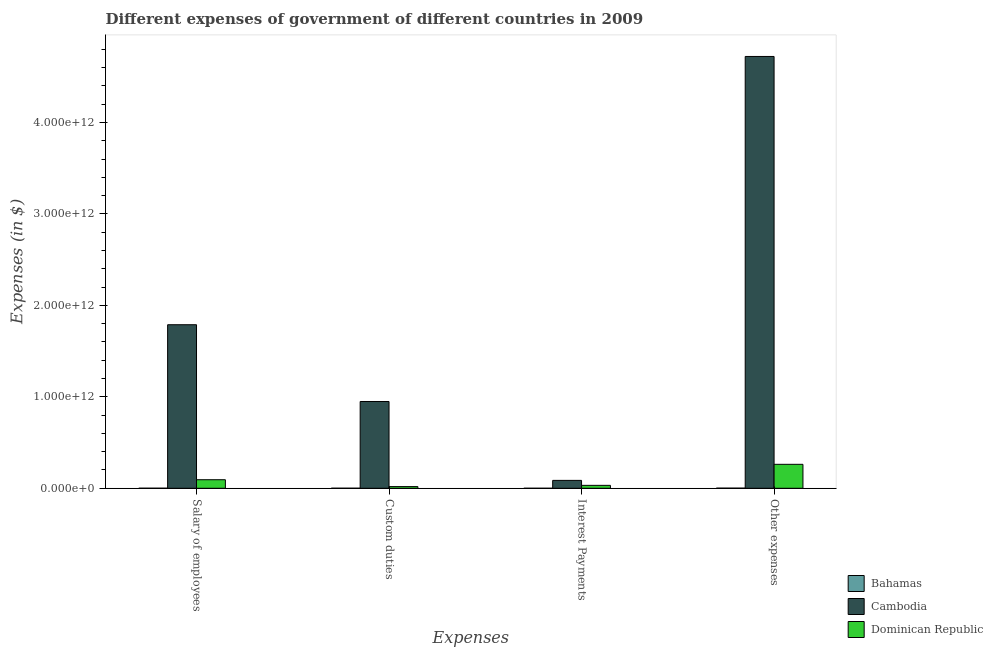How many different coloured bars are there?
Provide a succinct answer. 3. How many groups of bars are there?
Your response must be concise. 4. Are the number of bars on each tick of the X-axis equal?
Offer a very short reply. Yes. How many bars are there on the 2nd tick from the left?
Your response must be concise. 3. How many bars are there on the 2nd tick from the right?
Offer a very short reply. 3. What is the label of the 2nd group of bars from the left?
Your answer should be very brief. Custom duties. What is the amount spent on other expenses in Cambodia?
Your answer should be compact. 4.72e+12. Across all countries, what is the maximum amount spent on salary of employees?
Offer a terse response. 1.79e+12. Across all countries, what is the minimum amount spent on other expenses?
Keep it short and to the point. 1.42e+09. In which country was the amount spent on other expenses maximum?
Provide a succinct answer. Cambodia. In which country was the amount spent on salary of employees minimum?
Give a very brief answer. Bahamas. What is the total amount spent on custom duties in the graph?
Offer a terse response. 9.68e+11. What is the difference between the amount spent on other expenses in Cambodia and that in Bahamas?
Give a very brief answer. 4.72e+12. What is the difference between the amount spent on salary of employees in Cambodia and the amount spent on other expenses in Bahamas?
Give a very brief answer. 1.79e+12. What is the average amount spent on custom duties per country?
Your answer should be very brief. 3.23e+11. What is the difference between the amount spent on salary of employees and amount spent on custom duties in Bahamas?
Your response must be concise. -8.94e+06. In how many countries, is the amount spent on interest payments greater than 3800000000000 $?
Make the answer very short. 0. What is the ratio of the amount spent on other expenses in Bahamas to that in Cambodia?
Give a very brief answer. 0. Is the amount spent on other expenses in Dominican Republic less than that in Bahamas?
Keep it short and to the point. No. What is the difference between the highest and the second highest amount spent on other expenses?
Your response must be concise. 4.46e+12. What is the difference between the highest and the lowest amount spent on custom duties?
Keep it short and to the point. 9.48e+11. Is the sum of the amount spent on interest payments in Bahamas and Dominican Republic greater than the maximum amount spent on salary of employees across all countries?
Keep it short and to the point. No. Is it the case that in every country, the sum of the amount spent on salary of employees and amount spent on custom duties is greater than the sum of amount spent on interest payments and amount spent on other expenses?
Your response must be concise. No. What does the 2nd bar from the left in Interest Payments represents?
Provide a succinct answer. Cambodia. What does the 1st bar from the right in Other expenses represents?
Ensure brevity in your answer.  Dominican Republic. How many bars are there?
Keep it short and to the point. 12. Are all the bars in the graph horizontal?
Offer a terse response. No. How many countries are there in the graph?
Provide a succinct answer. 3. What is the difference between two consecutive major ticks on the Y-axis?
Offer a very short reply. 1.00e+12. Does the graph contain any zero values?
Give a very brief answer. No. Where does the legend appear in the graph?
Offer a terse response. Bottom right. What is the title of the graph?
Ensure brevity in your answer.  Different expenses of government of different countries in 2009. Does "Vanuatu" appear as one of the legend labels in the graph?
Ensure brevity in your answer.  No. What is the label or title of the X-axis?
Provide a short and direct response. Expenses. What is the label or title of the Y-axis?
Give a very brief answer. Expenses (in $). What is the Expenses (in $) of Bahamas in Salary of employees?
Ensure brevity in your answer.  5.73e+08. What is the Expenses (in $) of Cambodia in Salary of employees?
Provide a succinct answer. 1.79e+12. What is the Expenses (in $) of Dominican Republic in Salary of employees?
Your answer should be compact. 9.35e+1. What is the Expenses (in $) of Bahamas in Custom duties?
Offer a terse response. 5.82e+08. What is the Expenses (in $) of Cambodia in Custom duties?
Make the answer very short. 9.49e+11. What is the Expenses (in $) in Dominican Republic in Custom duties?
Ensure brevity in your answer.  1.83e+1. What is the Expenses (in $) of Bahamas in Interest Payments?
Keep it short and to the point. 1.54e+08. What is the Expenses (in $) in Cambodia in Interest Payments?
Keep it short and to the point. 8.63e+1. What is the Expenses (in $) of Dominican Republic in Interest Payments?
Give a very brief answer. 3.20e+1. What is the Expenses (in $) in Bahamas in Other expenses?
Your response must be concise. 1.42e+09. What is the Expenses (in $) of Cambodia in Other expenses?
Offer a very short reply. 4.72e+12. What is the Expenses (in $) of Dominican Republic in Other expenses?
Your answer should be very brief. 2.62e+11. Across all Expenses, what is the maximum Expenses (in $) in Bahamas?
Your answer should be compact. 1.42e+09. Across all Expenses, what is the maximum Expenses (in $) in Cambodia?
Offer a terse response. 4.72e+12. Across all Expenses, what is the maximum Expenses (in $) of Dominican Republic?
Provide a short and direct response. 2.62e+11. Across all Expenses, what is the minimum Expenses (in $) of Bahamas?
Offer a very short reply. 1.54e+08. Across all Expenses, what is the minimum Expenses (in $) of Cambodia?
Your answer should be very brief. 8.63e+1. Across all Expenses, what is the minimum Expenses (in $) of Dominican Republic?
Your answer should be compact. 1.83e+1. What is the total Expenses (in $) of Bahamas in the graph?
Offer a very short reply. 2.73e+09. What is the total Expenses (in $) of Cambodia in the graph?
Your response must be concise. 7.55e+12. What is the total Expenses (in $) in Dominican Republic in the graph?
Your response must be concise. 4.06e+11. What is the difference between the Expenses (in $) in Bahamas in Salary of employees and that in Custom duties?
Provide a succinct answer. -8.94e+06. What is the difference between the Expenses (in $) in Cambodia in Salary of employees and that in Custom duties?
Provide a short and direct response. 8.39e+11. What is the difference between the Expenses (in $) of Dominican Republic in Salary of employees and that in Custom duties?
Keep it short and to the point. 7.52e+1. What is the difference between the Expenses (in $) in Bahamas in Salary of employees and that in Interest Payments?
Offer a terse response. 4.19e+08. What is the difference between the Expenses (in $) of Cambodia in Salary of employees and that in Interest Payments?
Provide a short and direct response. 1.70e+12. What is the difference between the Expenses (in $) in Dominican Republic in Salary of employees and that in Interest Payments?
Provide a succinct answer. 6.15e+1. What is the difference between the Expenses (in $) of Bahamas in Salary of employees and that in Other expenses?
Make the answer very short. -8.49e+08. What is the difference between the Expenses (in $) in Cambodia in Salary of employees and that in Other expenses?
Your answer should be compact. -2.93e+12. What is the difference between the Expenses (in $) of Dominican Republic in Salary of employees and that in Other expenses?
Offer a terse response. -1.69e+11. What is the difference between the Expenses (in $) in Bahamas in Custom duties and that in Interest Payments?
Keep it short and to the point. 4.28e+08. What is the difference between the Expenses (in $) in Cambodia in Custom duties and that in Interest Payments?
Make the answer very short. 8.63e+11. What is the difference between the Expenses (in $) of Dominican Republic in Custom duties and that in Interest Payments?
Provide a succinct answer. -1.37e+1. What is the difference between the Expenses (in $) in Bahamas in Custom duties and that in Other expenses?
Offer a very short reply. -8.40e+08. What is the difference between the Expenses (in $) in Cambodia in Custom duties and that in Other expenses?
Your answer should be compact. -3.77e+12. What is the difference between the Expenses (in $) of Dominican Republic in Custom duties and that in Other expenses?
Your answer should be compact. -2.44e+11. What is the difference between the Expenses (in $) in Bahamas in Interest Payments and that in Other expenses?
Your answer should be very brief. -1.27e+09. What is the difference between the Expenses (in $) in Cambodia in Interest Payments and that in Other expenses?
Give a very brief answer. -4.64e+12. What is the difference between the Expenses (in $) of Dominican Republic in Interest Payments and that in Other expenses?
Your response must be concise. -2.30e+11. What is the difference between the Expenses (in $) in Bahamas in Salary of employees and the Expenses (in $) in Cambodia in Custom duties?
Your answer should be very brief. -9.48e+11. What is the difference between the Expenses (in $) of Bahamas in Salary of employees and the Expenses (in $) of Dominican Republic in Custom duties?
Your answer should be very brief. -1.77e+1. What is the difference between the Expenses (in $) in Cambodia in Salary of employees and the Expenses (in $) in Dominican Republic in Custom duties?
Offer a terse response. 1.77e+12. What is the difference between the Expenses (in $) of Bahamas in Salary of employees and the Expenses (in $) of Cambodia in Interest Payments?
Give a very brief answer. -8.57e+1. What is the difference between the Expenses (in $) of Bahamas in Salary of employees and the Expenses (in $) of Dominican Republic in Interest Payments?
Provide a short and direct response. -3.14e+1. What is the difference between the Expenses (in $) in Cambodia in Salary of employees and the Expenses (in $) in Dominican Republic in Interest Payments?
Offer a very short reply. 1.76e+12. What is the difference between the Expenses (in $) in Bahamas in Salary of employees and the Expenses (in $) in Cambodia in Other expenses?
Your response must be concise. -4.72e+12. What is the difference between the Expenses (in $) in Bahamas in Salary of employees and the Expenses (in $) in Dominican Republic in Other expenses?
Provide a succinct answer. -2.61e+11. What is the difference between the Expenses (in $) of Cambodia in Salary of employees and the Expenses (in $) of Dominican Republic in Other expenses?
Provide a succinct answer. 1.53e+12. What is the difference between the Expenses (in $) of Bahamas in Custom duties and the Expenses (in $) of Cambodia in Interest Payments?
Keep it short and to the point. -8.57e+1. What is the difference between the Expenses (in $) of Bahamas in Custom duties and the Expenses (in $) of Dominican Republic in Interest Payments?
Ensure brevity in your answer.  -3.14e+1. What is the difference between the Expenses (in $) of Cambodia in Custom duties and the Expenses (in $) of Dominican Republic in Interest Payments?
Offer a very short reply. 9.17e+11. What is the difference between the Expenses (in $) in Bahamas in Custom duties and the Expenses (in $) in Cambodia in Other expenses?
Give a very brief answer. -4.72e+12. What is the difference between the Expenses (in $) of Bahamas in Custom duties and the Expenses (in $) of Dominican Republic in Other expenses?
Give a very brief answer. -2.61e+11. What is the difference between the Expenses (in $) of Cambodia in Custom duties and the Expenses (in $) of Dominican Republic in Other expenses?
Provide a short and direct response. 6.87e+11. What is the difference between the Expenses (in $) of Bahamas in Interest Payments and the Expenses (in $) of Cambodia in Other expenses?
Provide a short and direct response. -4.72e+12. What is the difference between the Expenses (in $) in Bahamas in Interest Payments and the Expenses (in $) in Dominican Republic in Other expenses?
Make the answer very short. -2.62e+11. What is the difference between the Expenses (in $) in Cambodia in Interest Payments and the Expenses (in $) in Dominican Republic in Other expenses?
Provide a succinct answer. -1.76e+11. What is the average Expenses (in $) in Bahamas per Expenses?
Give a very brief answer. 6.83e+08. What is the average Expenses (in $) of Cambodia per Expenses?
Provide a short and direct response. 1.89e+12. What is the average Expenses (in $) of Dominican Republic per Expenses?
Offer a very short reply. 1.01e+11. What is the difference between the Expenses (in $) of Bahamas and Expenses (in $) of Cambodia in Salary of employees?
Keep it short and to the point. -1.79e+12. What is the difference between the Expenses (in $) in Bahamas and Expenses (in $) in Dominican Republic in Salary of employees?
Ensure brevity in your answer.  -9.29e+1. What is the difference between the Expenses (in $) in Cambodia and Expenses (in $) in Dominican Republic in Salary of employees?
Offer a terse response. 1.69e+12. What is the difference between the Expenses (in $) of Bahamas and Expenses (in $) of Cambodia in Custom duties?
Provide a short and direct response. -9.48e+11. What is the difference between the Expenses (in $) in Bahamas and Expenses (in $) in Dominican Republic in Custom duties?
Ensure brevity in your answer.  -1.77e+1. What is the difference between the Expenses (in $) of Cambodia and Expenses (in $) of Dominican Republic in Custom duties?
Provide a succinct answer. 9.31e+11. What is the difference between the Expenses (in $) of Bahamas and Expenses (in $) of Cambodia in Interest Payments?
Your answer should be very brief. -8.62e+1. What is the difference between the Expenses (in $) of Bahamas and Expenses (in $) of Dominican Republic in Interest Payments?
Provide a succinct answer. -3.19e+1. What is the difference between the Expenses (in $) of Cambodia and Expenses (in $) of Dominican Republic in Interest Payments?
Provide a short and direct response. 5.43e+1. What is the difference between the Expenses (in $) in Bahamas and Expenses (in $) in Cambodia in Other expenses?
Your response must be concise. -4.72e+12. What is the difference between the Expenses (in $) in Bahamas and Expenses (in $) in Dominican Republic in Other expenses?
Ensure brevity in your answer.  -2.61e+11. What is the difference between the Expenses (in $) of Cambodia and Expenses (in $) of Dominican Republic in Other expenses?
Ensure brevity in your answer.  4.46e+12. What is the ratio of the Expenses (in $) in Bahamas in Salary of employees to that in Custom duties?
Your answer should be very brief. 0.98. What is the ratio of the Expenses (in $) of Cambodia in Salary of employees to that in Custom duties?
Ensure brevity in your answer.  1.88. What is the ratio of the Expenses (in $) in Dominican Republic in Salary of employees to that in Custom duties?
Ensure brevity in your answer.  5.11. What is the ratio of the Expenses (in $) in Bahamas in Salary of employees to that in Interest Payments?
Give a very brief answer. 3.72. What is the ratio of the Expenses (in $) of Cambodia in Salary of employees to that in Interest Payments?
Offer a terse response. 20.72. What is the ratio of the Expenses (in $) of Dominican Republic in Salary of employees to that in Interest Payments?
Provide a succinct answer. 2.92. What is the ratio of the Expenses (in $) of Bahamas in Salary of employees to that in Other expenses?
Offer a very short reply. 0.4. What is the ratio of the Expenses (in $) of Cambodia in Salary of employees to that in Other expenses?
Provide a succinct answer. 0.38. What is the ratio of the Expenses (in $) of Dominican Republic in Salary of employees to that in Other expenses?
Make the answer very short. 0.36. What is the ratio of the Expenses (in $) in Bahamas in Custom duties to that in Interest Payments?
Offer a terse response. 3.77. What is the ratio of the Expenses (in $) in Cambodia in Custom duties to that in Interest Payments?
Give a very brief answer. 11. What is the ratio of the Expenses (in $) in Dominican Republic in Custom duties to that in Interest Payments?
Your answer should be very brief. 0.57. What is the ratio of the Expenses (in $) of Bahamas in Custom duties to that in Other expenses?
Your answer should be very brief. 0.41. What is the ratio of the Expenses (in $) of Cambodia in Custom duties to that in Other expenses?
Your answer should be very brief. 0.2. What is the ratio of the Expenses (in $) in Dominican Republic in Custom duties to that in Other expenses?
Provide a short and direct response. 0.07. What is the ratio of the Expenses (in $) of Bahamas in Interest Payments to that in Other expenses?
Give a very brief answer. 0.11. What is the ratio of the Expenses (in $) in Cambodia in Interest Payments to that in Other expenses?
Give a very brief answer. 0.02. What is the ratio of the Expenses (in $) in Dominican Republic in Interest Payments to that in Other expenses?
Make the answer very short. 0.12. What is the difference between the highest and the second highest Expenses (in $) of Bahamas?
Your answer should be compact. 8.40e+08. What is the difference between the highest and the second highest Expenses (in $) of Cambodia?
Make the answer very short. 2.93e+12. What is the difference between the highest and the second highest Expenses (in $) in Dominican Republic?
Offer a very short reply. 1.69e+11. What is the difference between the highest and the lowest Expenses (in $) of Bahamas?
Make the answer very short. 1.27e+09. What is the difference between the highest and the lowest Expenses (in $) in Cambodia?
Give a very brief answer. 4.64e+12. What is the difference between the highest and the lowest Expenses (in $) in Dominican Republic?
Keep it short and to the point. 2.44e+11. 